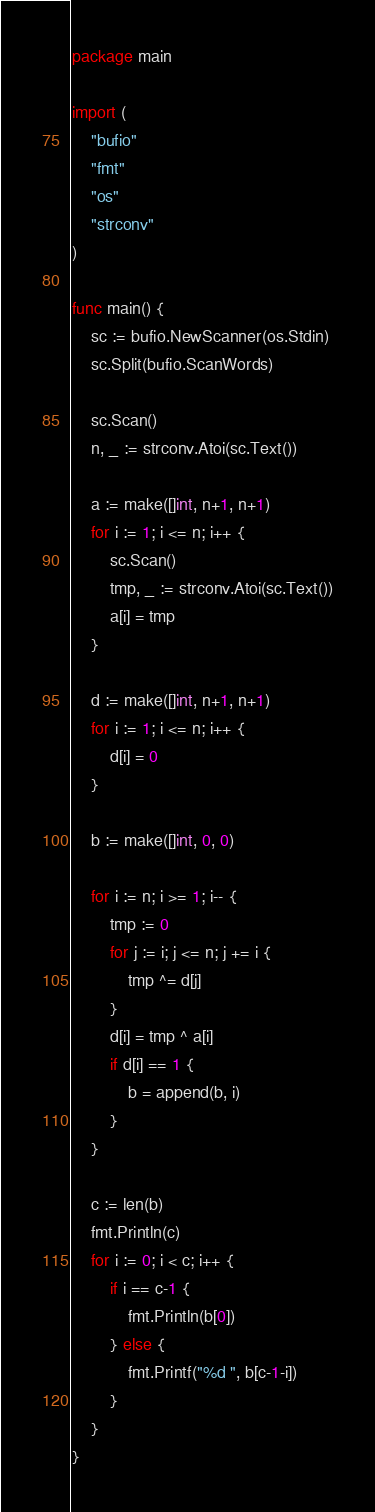Convert code to text. <code><loc_0><loc_0><loc_500><loc_500><_Go_>package main

import (
	"bufio"
	"fmt"
	"os"
	"strconv"
)

func main() {
	sc := bufio.NewScanner(os.Stdin)
	sc.Split(bufio.ScanWords)

	sc.Scan()
	n, _ := strconv.Atoi(sc.Text())

	a := make([]int, n+1, n+1)
	for i := 1; i <= n; i++ {
		sc.Scan()
		tmp, _ := strconv.Atoi(sc.Text())
		a[i] = tmp
	}

	d := make([]int, n+1, n+1)
	for i := 1; i <= n; i++ {
		d[i] = 0
	}

	b := make([]int, 0, 0)

	for i := n; i >= 1; i-- {
		tmp := 0
		for j := i; j <= n; j += i {
			tmp ^= d[j]
		}
		d[i] = tmp ^ a[i]
		if d[i] == 1 {
			b = append(b, i)
		}
	}

	c := len(b)
	fmt.Println(c)
	for i := 0; i < c; i++ {
		if i == c-1 {
			fmt.Println(b[0])
		} else {
			fmt.Printf("%d ", b[c-1-i])
		}
	}
}
</code> 